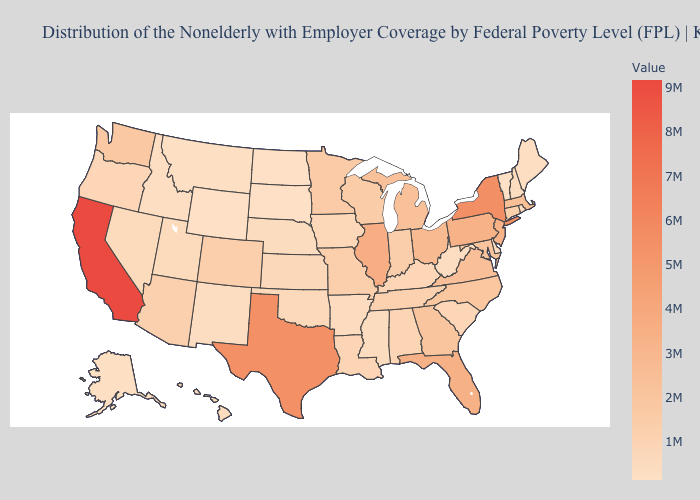Does Texas have the lowest value in the South?
Write a very short answer. No. Does New York have the highest value in the Northeast?
Short answer required. Yes. Does Wyoming have the lowest value in the USA?
Concise answer only. Yes. Which states have the highest value in the USA?
Answer briefly. California. Which states have the lowest value in the West?
Be succinct. Wyoming. Does Wyoming have the lowest value in the USA?
Be succinct. Yes. Does New York have the highest value in the Northeast?
Write a very short answer. Yes. 